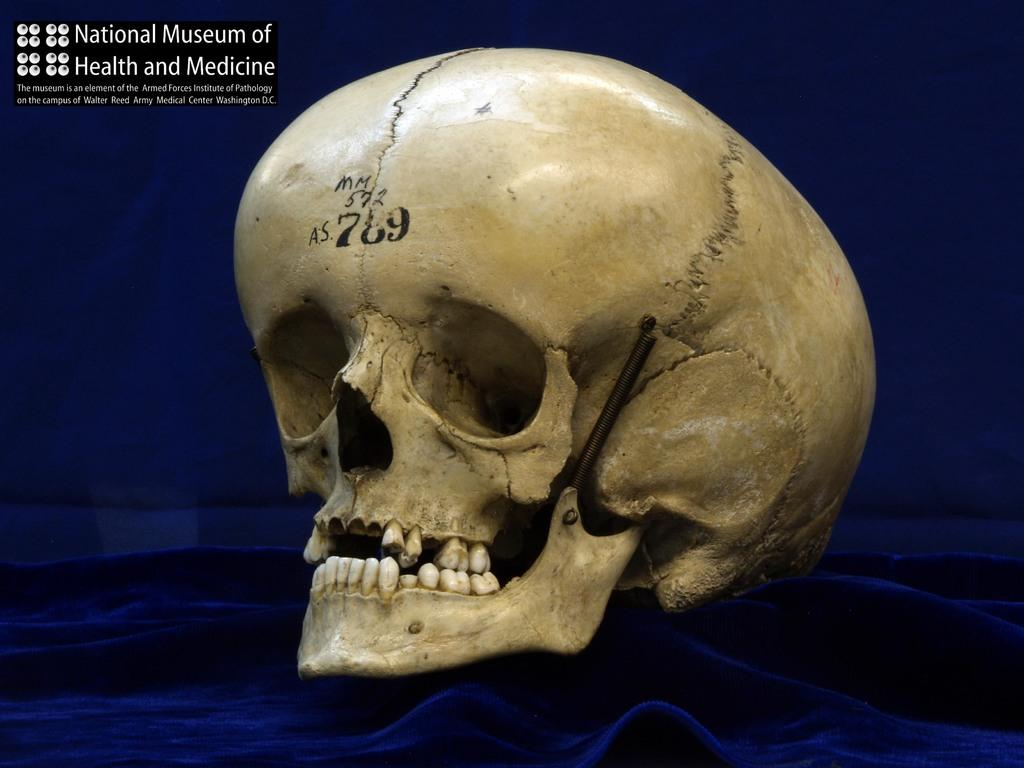What is the main subject in the foreground of the image? There is a skull in the foreground of the image. What is the skull placed on? The skull is on a blue cloth. What color is predominant in the background of the image? The background of the image is blue. Can you describe any text visible in the image? There is some text at the top of the image. What type of amusement can be seen in the image? There is no amusement present in the image; it features a skull on a blue cloth with some text at the top. Can you tell me how many men are wearing underwear in the image? There are no men or underwear visible in the image. 